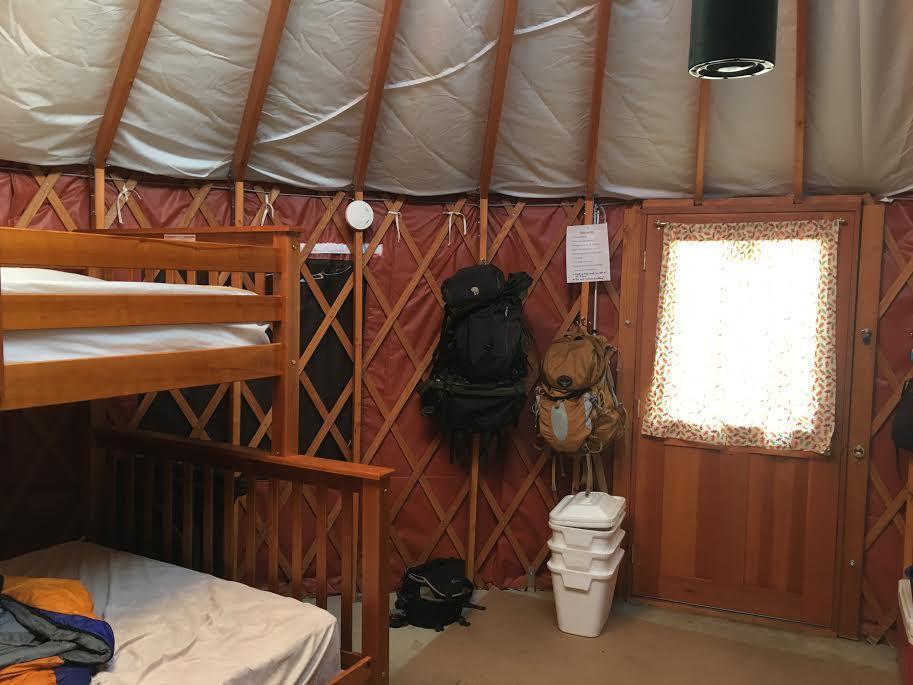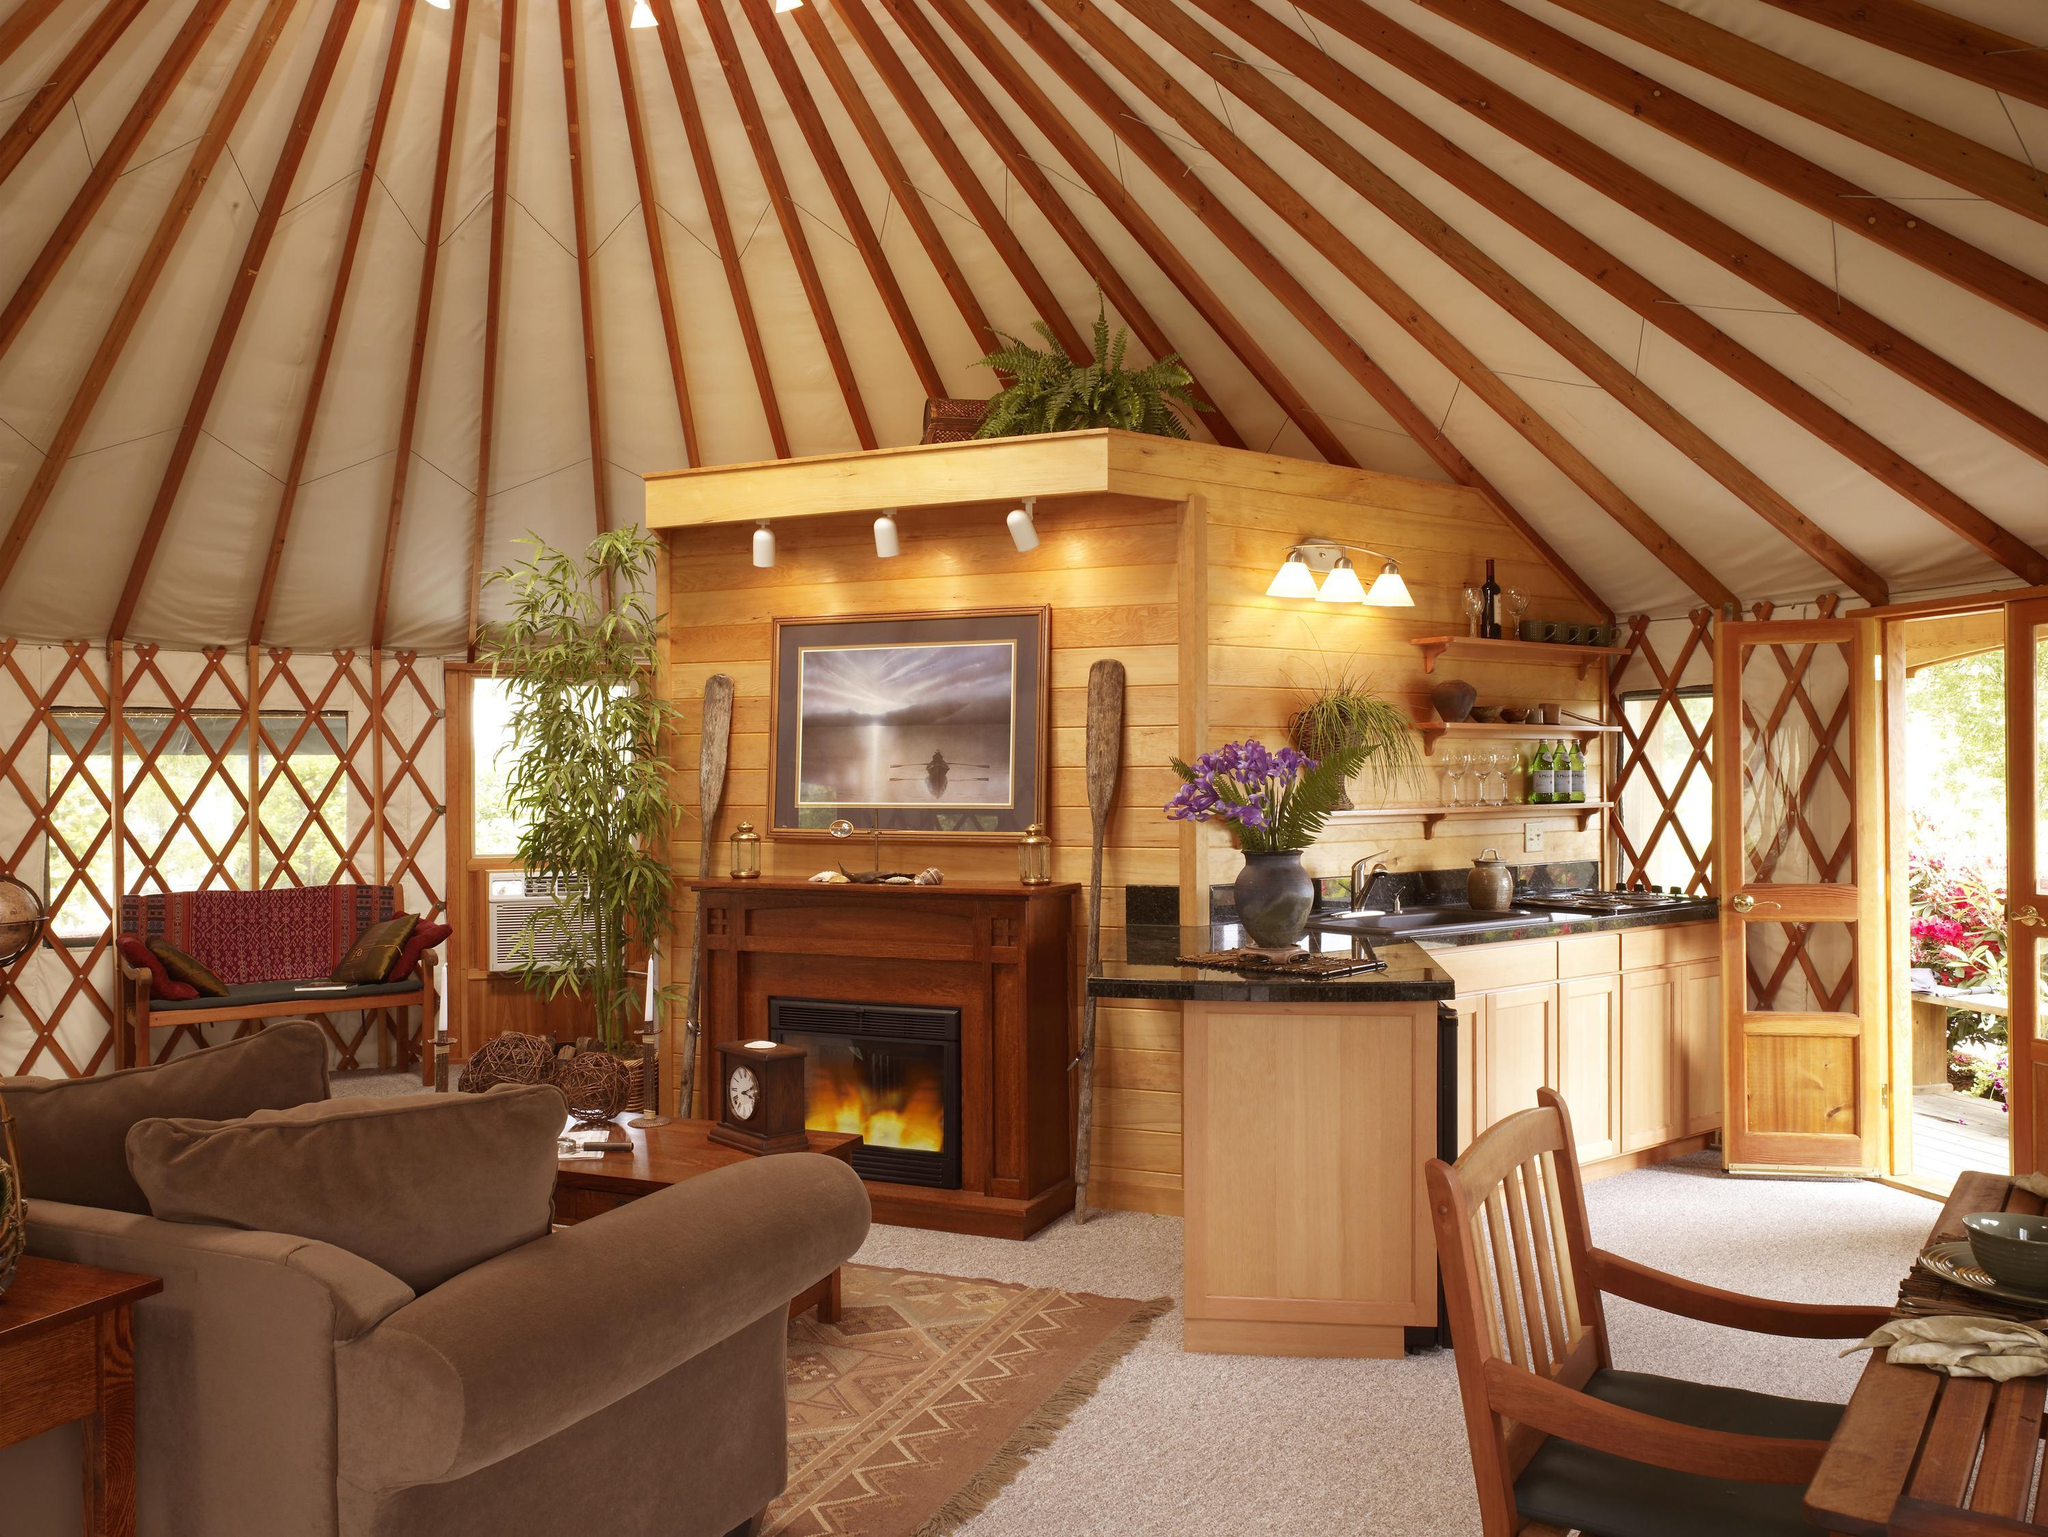The first image is the image on the left, the second image is the image on the right. Evaluate the accuracy of this statement regarding the images: "A ladder to a loft is standing at the right in an image of a yurt's interior.". Is it true? Answer yes or no. No. 